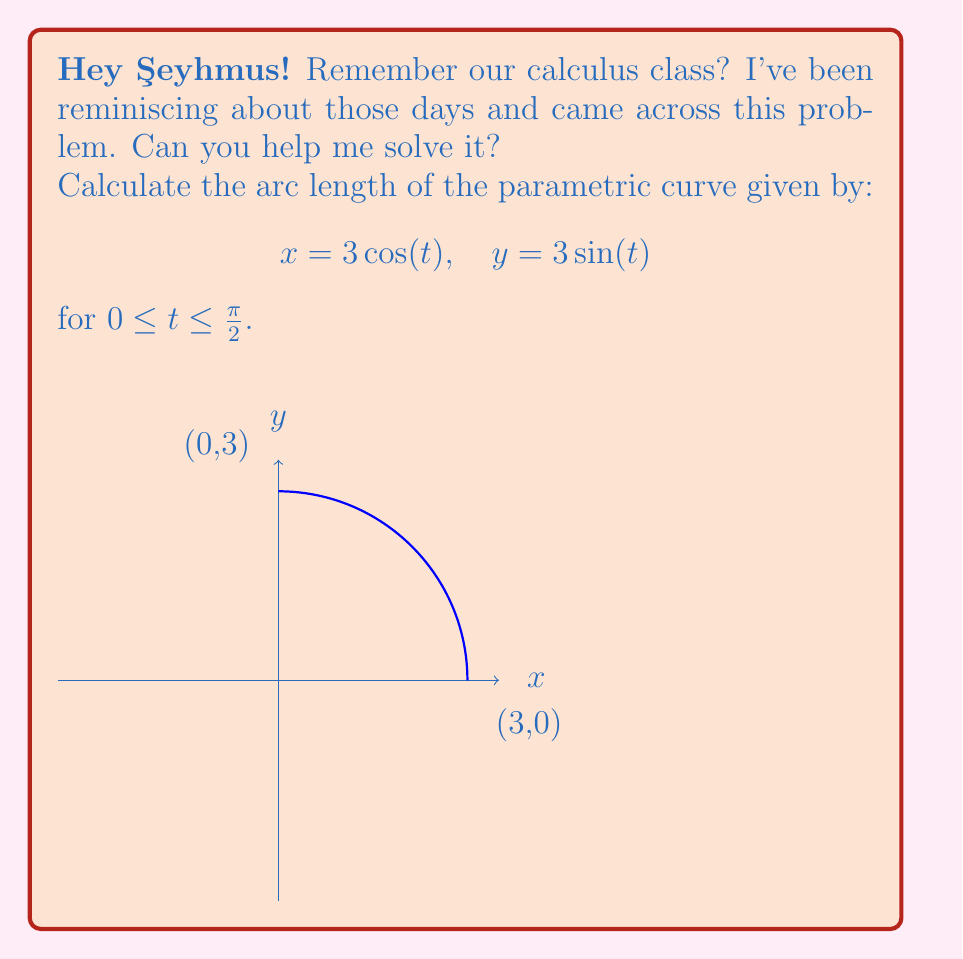Could you help me with this problem? Let's approach this step-by-step:

1) The formula for arc length of a parametric curve is:

   $$L = \int_a^b \sqrt{\left(\frac{dx}{dt}\right)^2 + \left(\frac{dy}{dt}\right)^2} dt$$

2) We need to find $\frac{dx}{dt}$ and $\frac{dy}{dt}$:
   
   $$\frac{dx}{dt} = -3\sin(t)$$
   $$\frac{dy}{dt} = 3\cos(t)$$

3) Now, let's substitute these into our arc length formula:

   $$L = \int_0^{\pi/2} \sqrt{(-3\sin(t))^2 + (3\cos(t))^2} dt$$

4) Simplify under the square root:

   $$L = \int_0^{\pi/2} \sqrt{9\sin^2(t) + 9\cos^2(t)} dt$$

5) Factor out the common factor:

   $$L = \int_0^{\pi/2} \sqrt{9(\sin^2(t) + \cos^2(t))} dt$$

6) Recall the trigonometric identity $\sin^2(t) + \cos^2(t) = 1$:

   $$L = \int_0^{\pi/2} \sqrt{9} dt = \int_0^{\pi/2} 3 dt$$

7) Integrate:

   $$L = 3t \bigg|_0^{\pi/2} = 3(\frac{\pi}{2} - 0) = \frac{3\pi}{2}$$

Thus, the arc length is $\frac{3\pi}{2}$.
Answer: $\frac{3\pi}{2}$ 